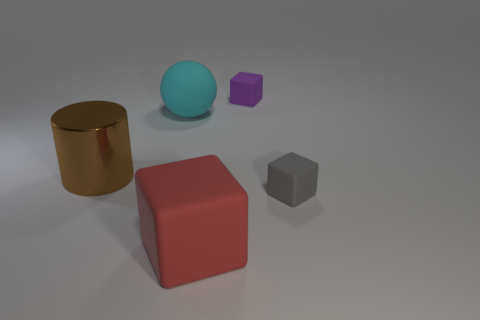Subtract all tiny purple blocks. How many blocks are left? 2 Add 2 cyan matte cubes. How many objects exist? 7 Subtract 1 cylinders. How many cylinders are left? 0 Subtract all cylinders. How many objects are left? 4 Subtract all gray cubes. How many cubes are left? 2 Subtract 1 gray blocks. How many objects are left? 4 Subtract all green balls. Subtract all brown cylinders. How many balls are left? 1 Subtract all big blue rubber cylinders. Subtract all purple rubber objects. How many objects are left? 4 Add 1 tiny purple things. How many tiny purple things are left? 2 Add 2 large red blocks. How many large red blocks exist? 3 